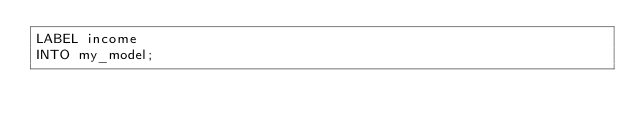<code> <loc_0><loc_0><loc_500><loc_500><_SQL_>LABEL income
INTO my_model;
</code> 